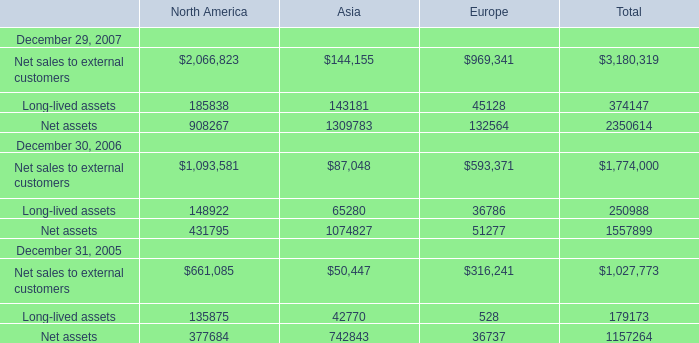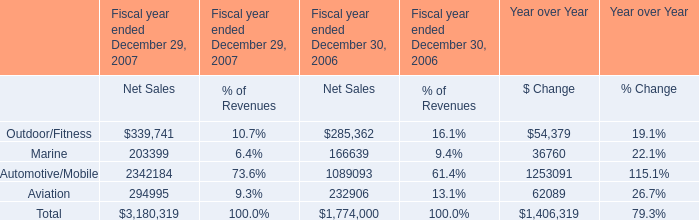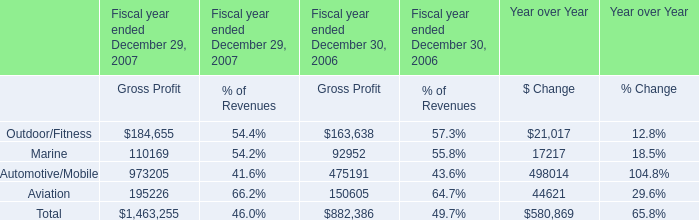What is the growing rate of Marine for Gross Profit in the years with the least Marine for Net Sales? (in Marine for Gross Profit) 
Computations: ((110169 - 92952) / 92952)
Answer: 0.18522. 